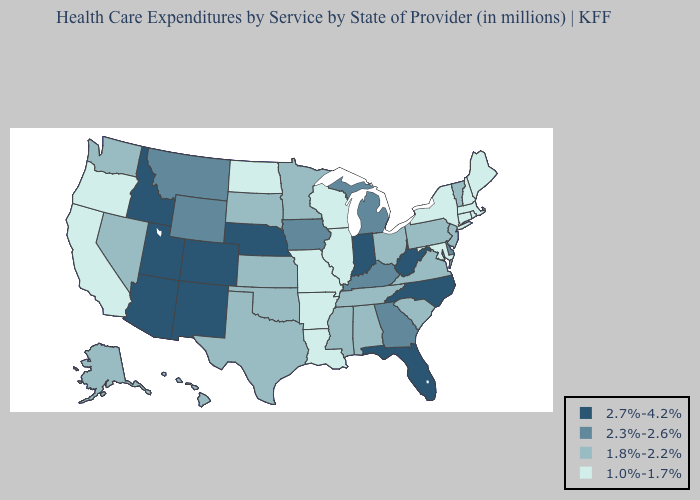What is the highest value in the South ?
Answer briefly. 2.7%-4.2%. Does Idaho have the highest value in the USA?
Give a very brief answer. Yes. What is the highest value in the South ?
Quick response, please. 2.7%-4.2%. What is the highest value in the West ?
Be succinct. 2.7%-4.2%. What is the value of Arizona?
Answer briefly. 2.7%-4.2%. What is the lowest value in the West?
Be succinct. 1.0%-1.7%. Among the states that border Missouri , which have the highest value?
Short answer required. Nebraska. What is the lowest value in the USA?
Concise answer only. 1.0%-1.7%. Is the legend a continuous bar?
Write a very short answer. No. Which states have the lowest value in the USA?
Answer briefly. Arkansas, California, Connecticut, Illinois, Louisiana, Maine, Maryland, Massachusetts, Missouri, New Hampshire, New York, North Dakota, Oregon, Rhode Island, Wisconsin. What is the value of New Hampshire?
Concise answer only. 1.0%-1.7%. Name the states that have a value in the range 1.0%-1.7%?
Quick response, please. Arkansas, California, Connecticut, Illinois, Louisiana, Maine, Maryland, Massachusetts, Missouri, New Hampshire, New York, North Dakota, Oregon, Rhode Island, Wisconsin. Name the states that have a value in the range 1.8%-2.2%?
Write a very short answer. Alabama, Alaska, Hawaii, Kansas, Minnesota, Mississippi, Nevada, New Jersey, Ohio, Oklahoma, Pennsylvania, South Carolina, South Dakota, Tennessee, Texas, Vermont, Virginia, Washington. Name the states that have a value in the range 1.0%-1.7%?
Concise answer only. Arkansas, California, Connecticut, Illinois, Louisiana, Maine, Maryland, Massachusetts, Missouri, New Hampshire, New York, North Dakota, Oregon, Rhode Island, Wisconsin. Does Delaware have the same value as South Carolina?
Concise answer only. No. 